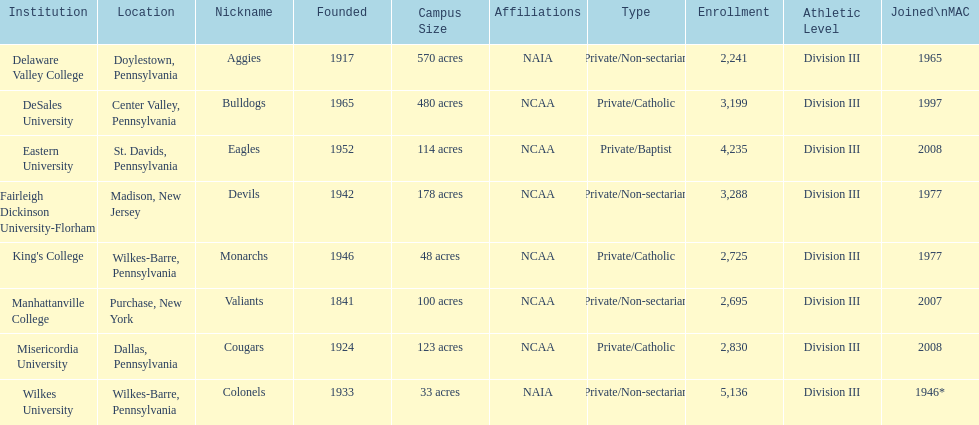What is the enrollment number of misericordia university? 2,830. 